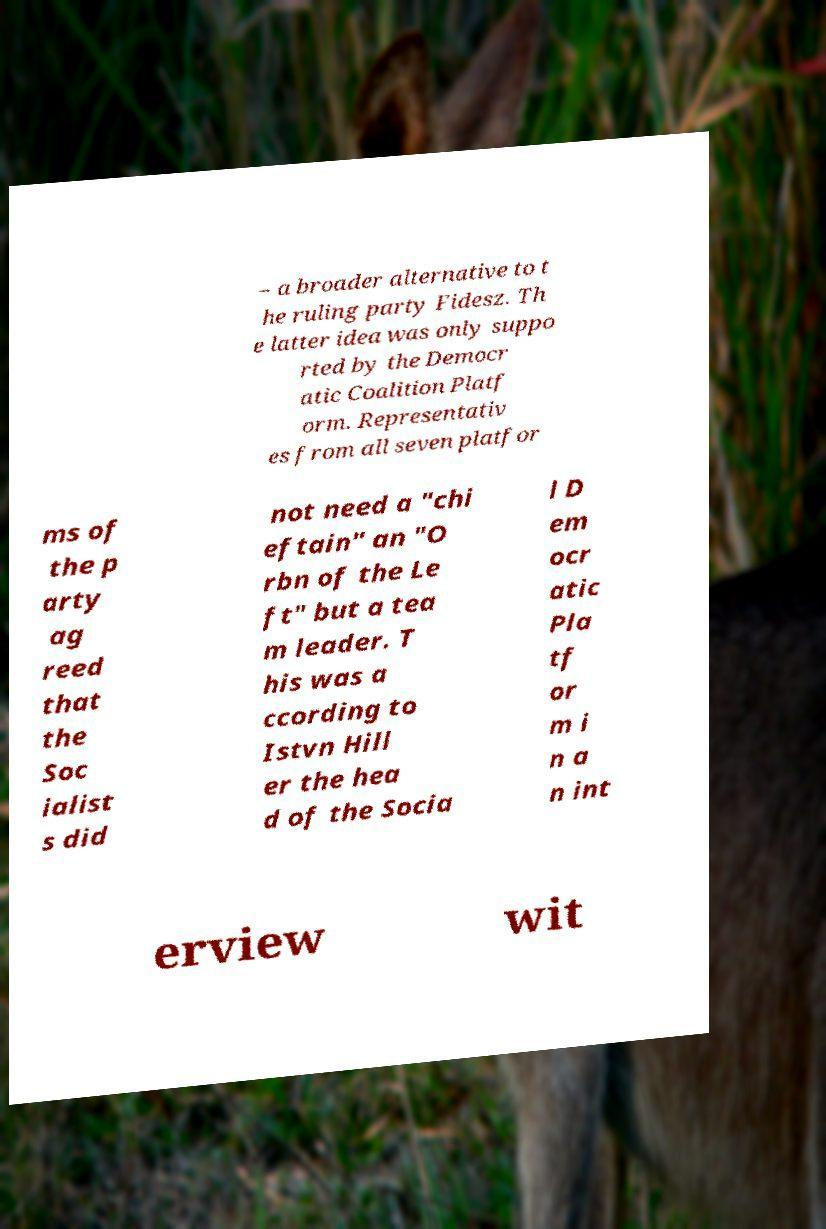Please identify and transcribe the text found in this image. – a broader alternative to t he ruling party Fidesz. Th e latter idea was only suppo rted by the Democr atic Coalition Platf orm. Representativ es from all seven platfor ms of the p arty ag reed that the Soc ialist s did not need a "chi eftain" an "O rbn of the Le ft" but a tea m leader. T his was a ccording to Istvn Hill er the hea d of the Socia l D em ocr atic Pla tf or m i n a n int erview wit 